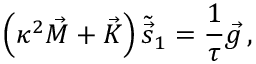Convert formula to latex. <formula><loc_0><loc_0><loc_500><loc_500>\left ( \kappa ^ { 2 } \vec { M } + \vec { K } \right ) \tilde { \vec { s } } _ { 1 } = \frac { 1 } { \tau } { \vec { g } } \, ,</formula> 